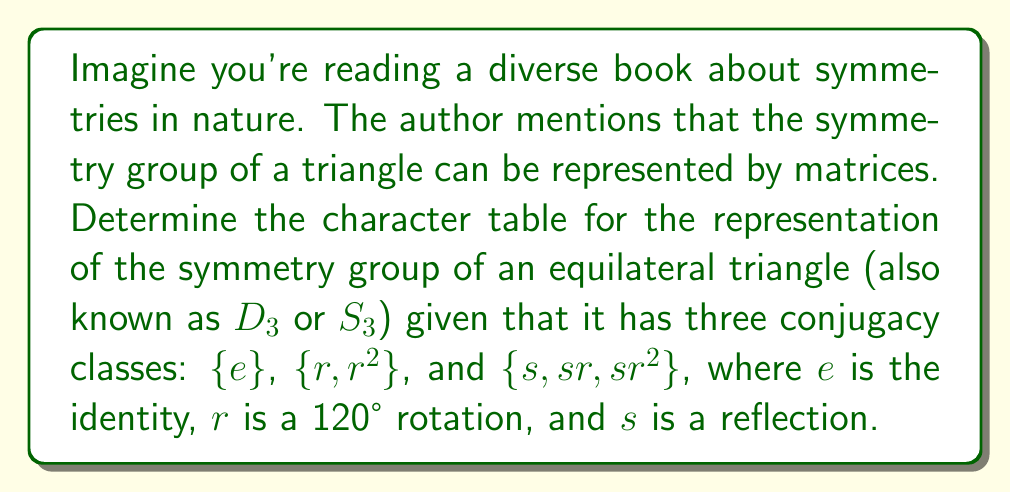Help me with this question. Let's approach this step-by-step:

1) First, recall that the number of irreducible representations equals the number of conjugacy classes. Here, we have 3 conjugacy classes, so we'll have 3 irreducible representations.

2) The dimensions of these irreducible representations must satisfy:
   $$ 1^2 + 1^2 + 2^2 = 6 $$
   where 6 is the order of the group. This suggests we have two 1-dimensional representations and one 2-dimensional representation.

3) Let's call these representations $\chi_1$ (trivial), $\chi_2$, and $\chi_3$ (2-dimensional).

4) $\chi_1$ is always (1, 1, 1) as it's the trivial representation.

5) For $\chi_2$, we know it must be 1-dimensional and different from $\chi_1$. It must also satisfy orthogonality with $\chi_1$. The only possibility is (1, 1, -1).

6) For $\chi_3$, we can use the fact that the sum of squares of the dimensions equals the order of the group:
   $$ \chi_3(e) = 2 $$

7) We can find $\chi_3(r)$ using the fact that the sum of the values in each column (except the first) must be zero:
   $$ 1 + 1 + \chi_3(r) = 0 $$
   $$ \chi_3(r) = -2 $$

8) Finally, we can find $\chi_3(s)$ using the orthogonality of characters:
   $$ 1 \cdot 1 + 2 \cdot 1 + 3 \cdot \chi_3(s) = 0 $$
   $$ \chi_3(s) = -1 $$

9) We can verify this satisfies all the properties of a character table.

The resulting character table is:

$$
\begin{array}{c|ccc}
D_3 & \{e\} & \{r,r^2\} & \{s,sr,sr^2\} \\
\hline
\chi_1 & 1 & 1 & 1 \\
\chi_2 & 1 & 1 & -1 \\
\chi_3 & 2 & -1 & 0
\end{array}
$$
Answer: $$
\begin{array}{c|ccc}
D_3 & \{e\} & \{r,r^2\} & \{s,sr,sr^2\} \\
\hline
\chi_1 & 1 & 1 & 1 \\
\chi_2 & 1 & 1 & -1 \\
\chi_3 & 2 & -1 & 0
\end{array}
$$ 